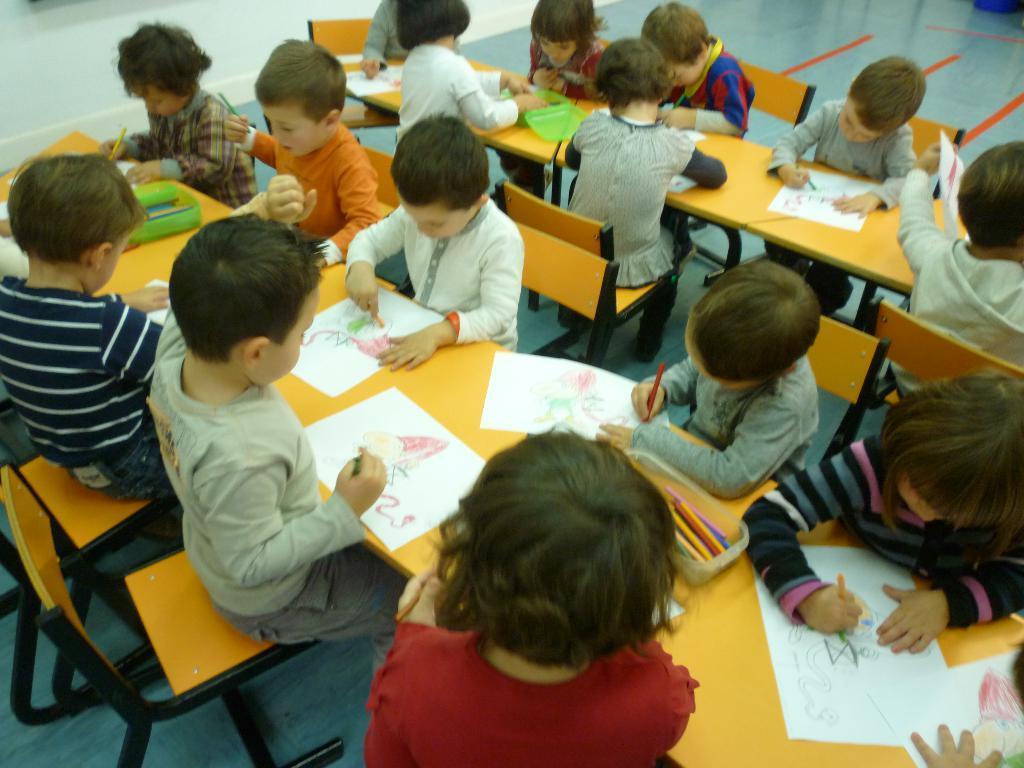In one or two sentences, can you explain what this image depicts? This is a picture of classroom. This is a floor. Here we can see all the students sitting on chairs in front of a table and they are drawing with colour pencils on a white paper. On the table we can see box of pencils. 